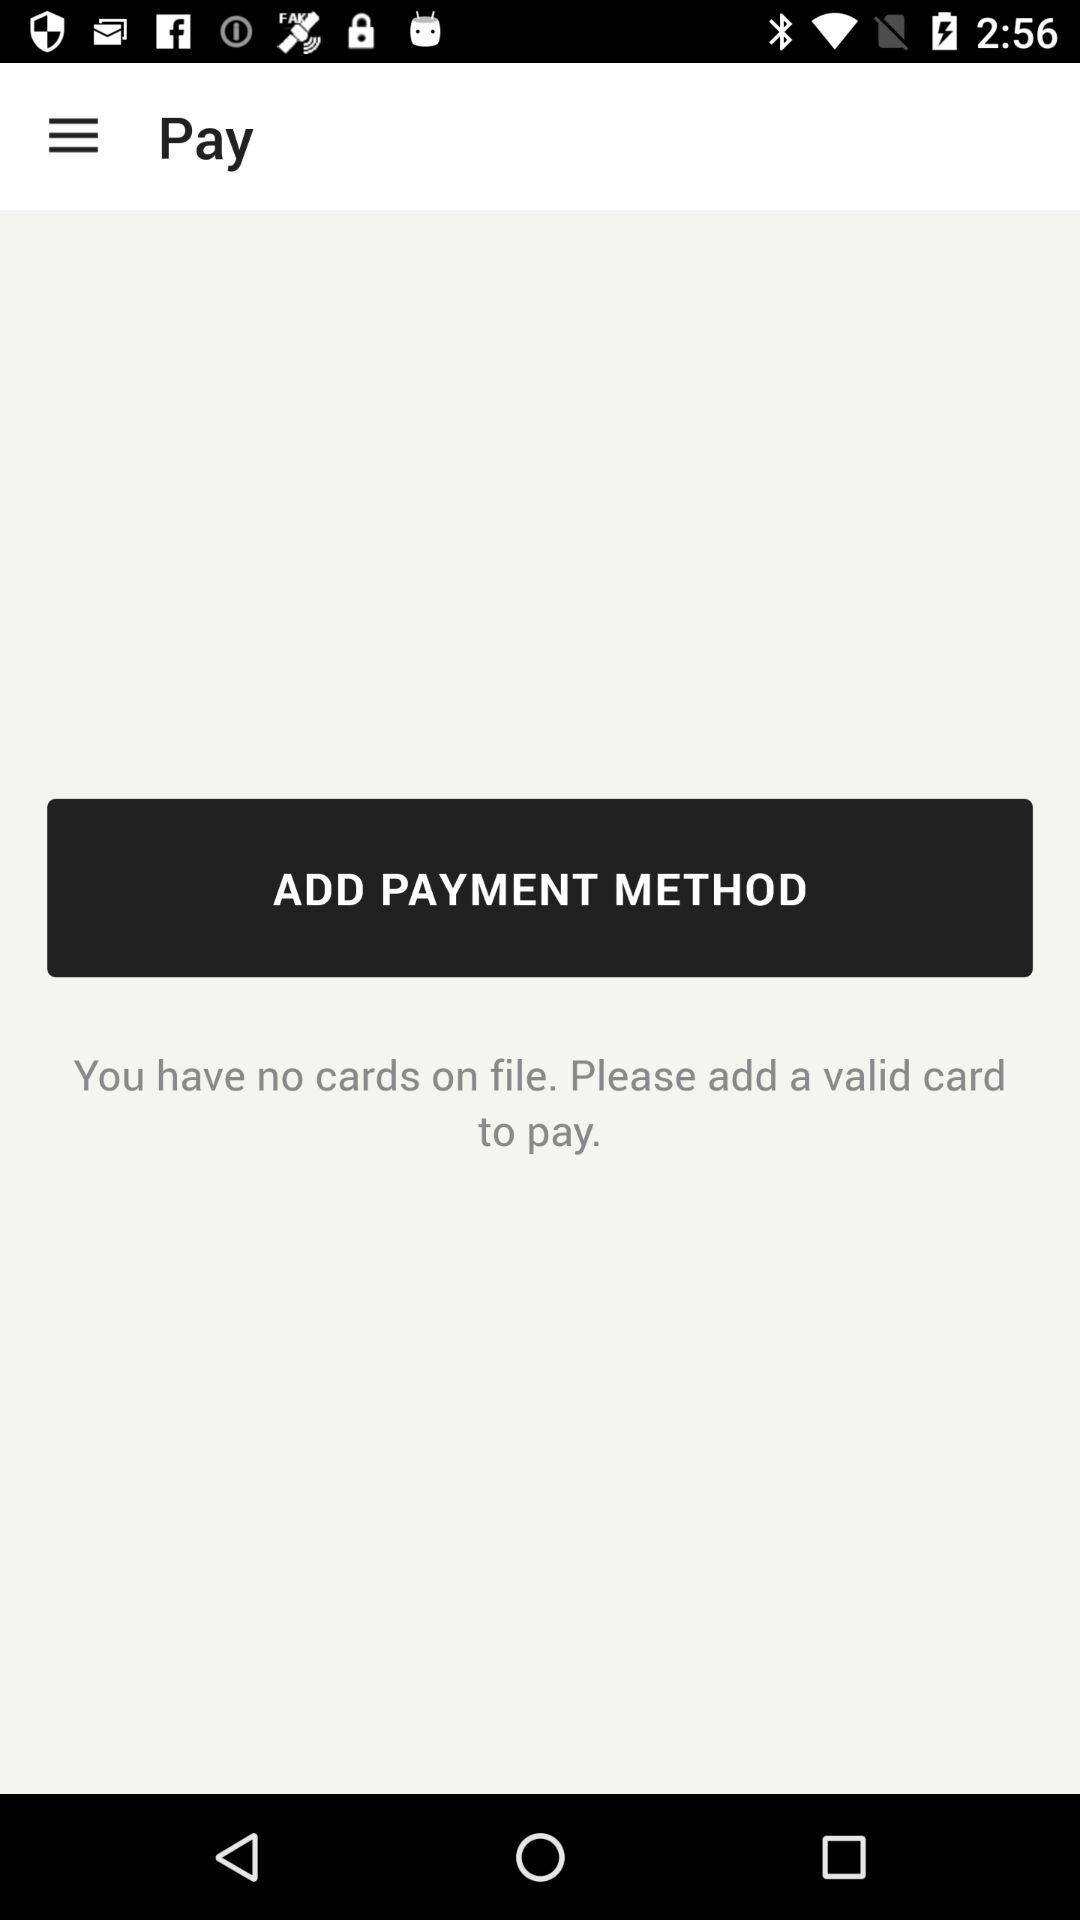How many cards are there on file? There are no cards on file. 